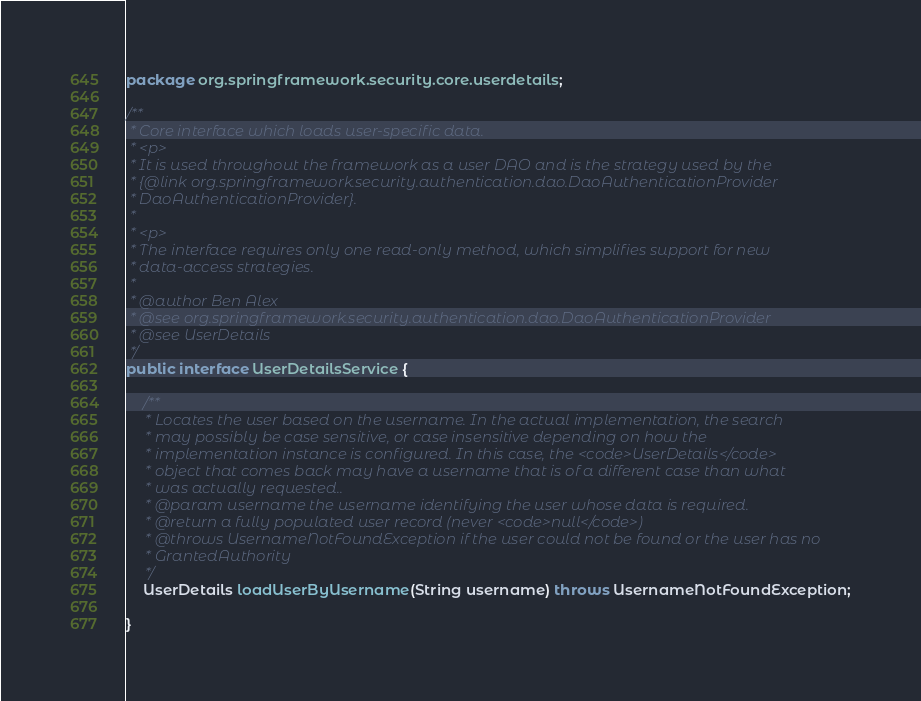<code> <loc_0><loc_0><loc_500><loc_500><_Java_>package org.springframework.security.core.userdetails;

/**
 * Core interface which loads user-specific data.
 * <p>
 * It is used throughout the framework as a user DAO and is the strategy used by the
 * {@link org.springframework.security.authentication.dao.DaoAuthenticationProvider
 * DaoAuthenticationProvider}.
 *
 * <p>
 * The interface requires only one read-only method, which simplifies support for new
 * data-access strategies.
 *
 * @author Ben Alex
 * @see org.springframework.security.authentication.dao.DaoAuthenticationProvider
 * @see UserDetails
 */
public interface UserDetailsService {

	/**
	 * Locates the user based on the username. In the actual implementation, the search
	 * may possibly be case sensitive, or case insensitive depending on how the
	 * implementation instance is configured. In this case, the <code>UserDetails</code>
	 * object that comes back may have a username that is of a different case than what
	 * was actually requested..
	 * @param username the username identifying the user whose data is required.
	 * @return a fully populated user record (never <code>null</code>)
	 * @throws UsernameNotFoundException if the user could not be found or the user has no
	 * GrantedAuthority
	 */
	UserDetails loadUserByUsername(String username) throws UsernameNotFoundException;

}
</code> 